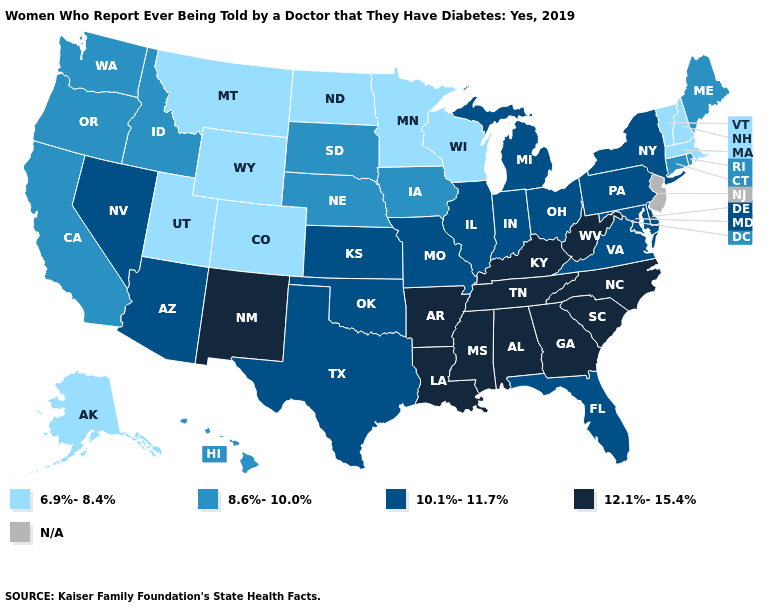Does South Dakota have the lowest value in the MidWest?
Give a very brief answer. No. Does Washington have the lowest value in the West?
Be succinct. No. What is the value of Nebraska?
Keep it brief. 8.6%-10.0%. Name the states that have a value in the range 12.1%-15.4%?
Write a very short answer. Alabama, Arkansas, Georgia, Kentucky, Louisiana, Mississippi, New Mexico, North Carolina, South Carolina, Tennessee, West Virginia. Among the states that border Connecticut , does New York have the lowest value?
Keep it brief. No. Does Washington have the highest value in the West?
Concise answer only. No. What is the value of Kentucky?
Give a very brief answer. 12.1%-15.4%. Name the states that have a value in the range 6.9%-8.4%?
Keep it brief. Alaska, Colorado, Massachusetts, Minnesota, Montana, New Hampshire, North Dakota, Utah, Vermont, Wisconsin, Wyoming. Among the states that border West Virginia , which have the highest value?
Write a very short answer. Kentucky. Does the map have missing data?
Quick response, please. Yes. Does the first symbol in the legend represent the smallest category?
Concise answer only. Yes. Which states have the lowest value in the USA?
Give a very brief answer. Alaska, Colorado, Massachusetts, Minnesota, Montana, New Hampshire, North Dakota, Utah, Vermont, Wisconsin, Wyoming. Is the legend a continuous bar?
Short answer required. No. What is the lowest value in the USA?
Give a very brief answer. 6.9%-8.4%. Does Alabama have the highest value in the USA?
Keep it brief. Yes. 